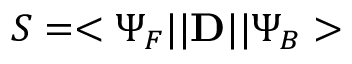Convert formula to latex. <formula><loc_0><loc_0><loc_500><loc_500>S = < \Psi _ { F } | | { D } | | \Psi _ { B } ></formula> 